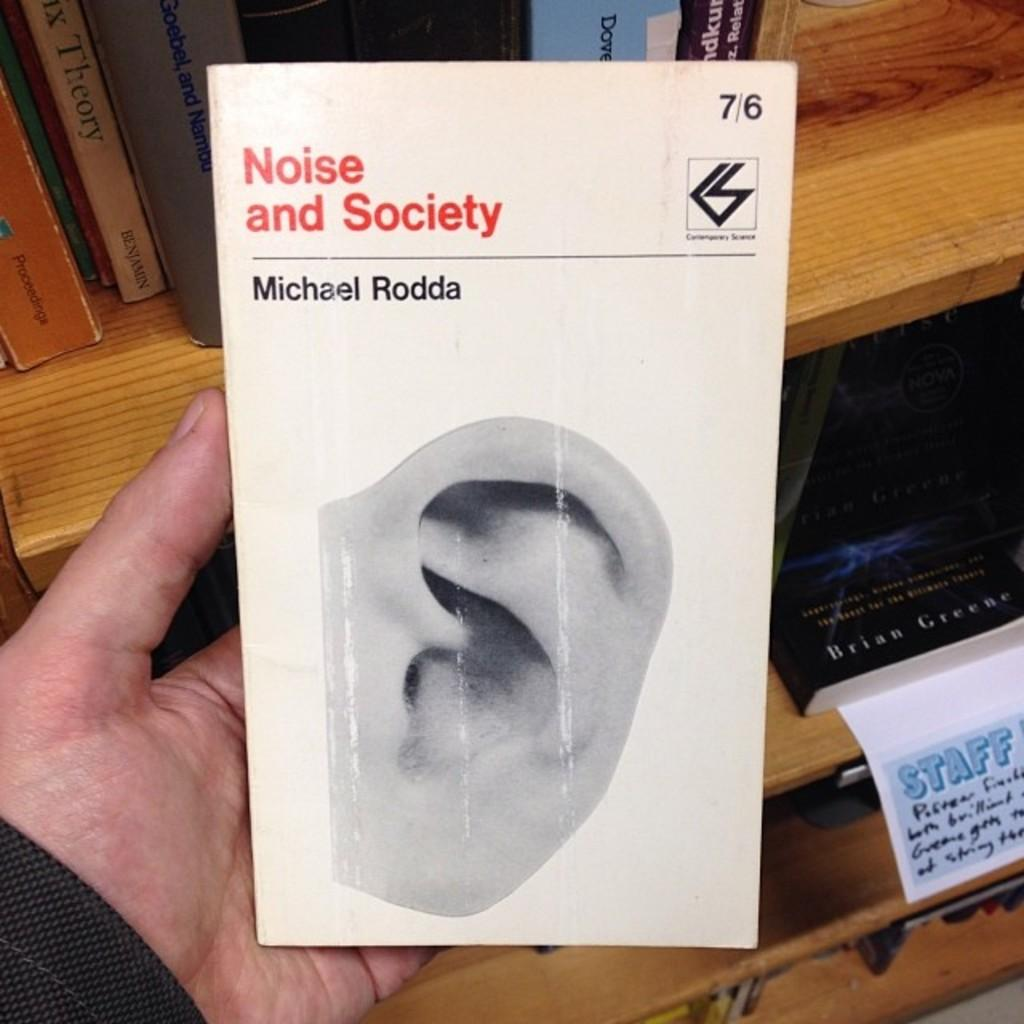<image>
Write a terse but informative summary of the picture. A book titled Noise and Society has an ear on the cover. 